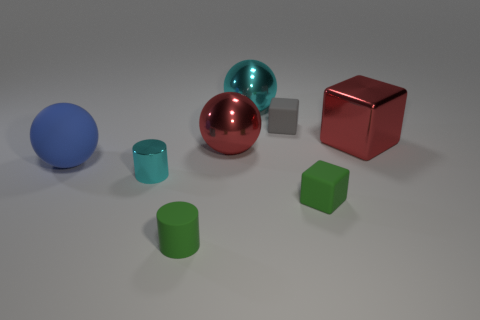There is a cyan object that is to the left of the cyan metal object that is behind the big blue thing; what is its size?
Give a very brief answer. Small. Are there any other things that are the same size as the red sphere?
Your answer should be compact. Yes. What is the material of the large blue thing that is the same shape as the big cyan thing?
Offer a terse response. Rubber. There is a gray thing right of the large red ball; does it have the same shape as the cyan object that is right of the matte cylinder?
Your response must be concise. No. Are there more tiny green cubes than tiny brown shiny balls?
Keep it short and to the point. Yes. What size is the red block?
Give a very brief answer. Large. How many other objects are the same color as the big rubber ball?
Give a very brief answer. 0. Are the red thing behind the red ball and the tiny cyan object made of the same material?
Provide a succinct answer. Yes. Are there fewer cyan metallic things left of the large matte thing than cyan things behind the cyan sphere?
Provide a succinct answer. No. What number of other things are made of the same material as the cyan cylinder?
Give a very brief answer. 3. 